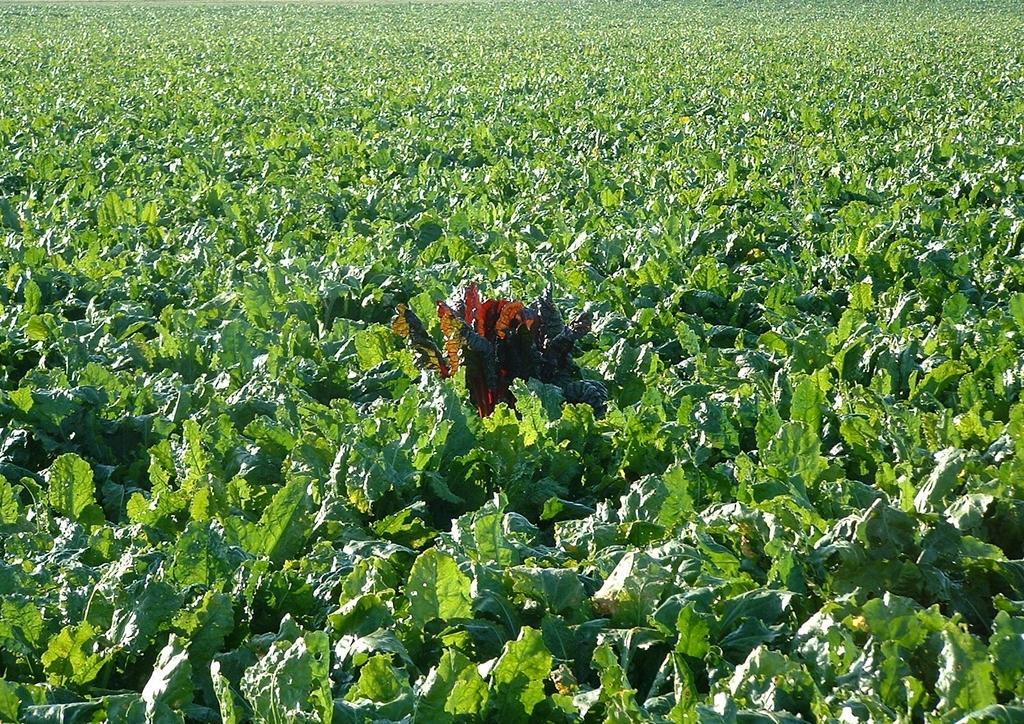How would you summarize this image in a sentence or two? Here we can see green plants. 